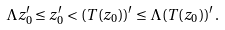<formula> <loc_0><loc_0><loc_500><loc_500>\Lambda z ^ { \prime } _ { 0 } \leq z ^ { \prime } _ { 0 } < ( T ( z _ { 0 } ) ) ^ { \prime } \leq \Lambda ( T ( z _ { 0 } ) ) ^ { \prime } \, .</formula> 